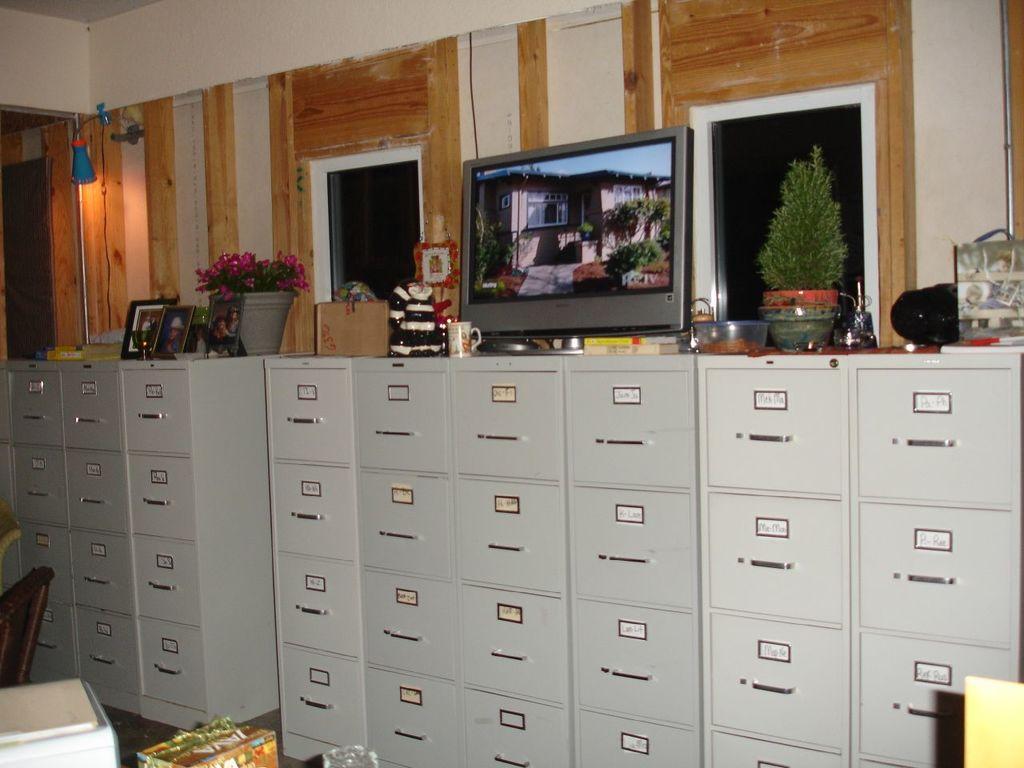In one or two sentences, can you explain what this image depicts? This is an inside view. Here I can see many lockers. On the lockers a monitor, flower pots, cups, photo frames, boxes and some other objects are placed. At the bottom, I can see few objects on the floor. In the background there is a wall. 